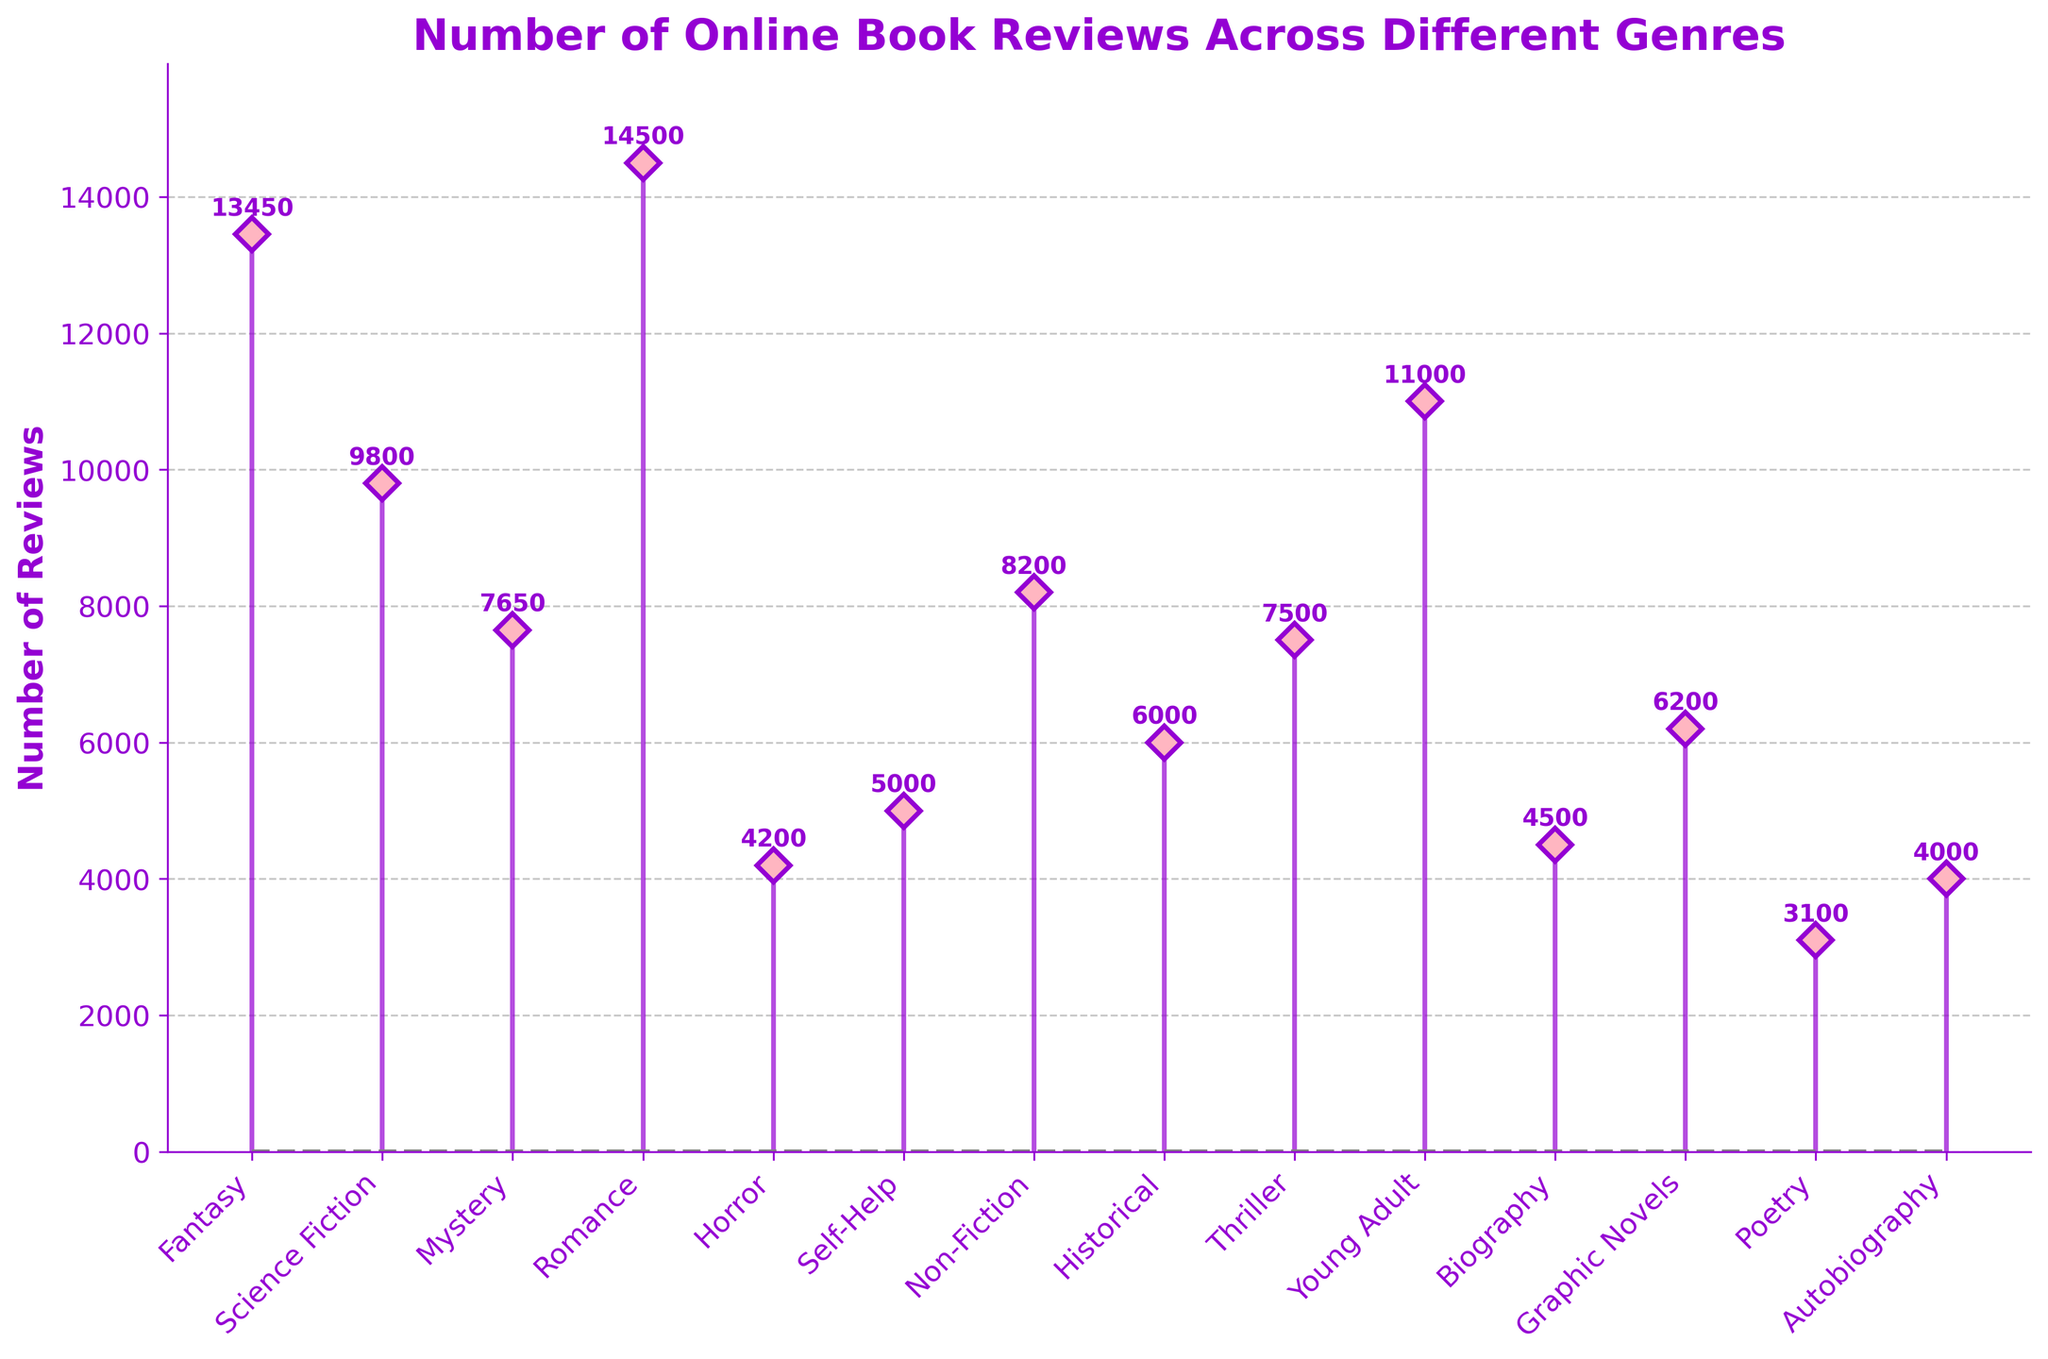What is the title of the plot? The title is usually displayed at the top of the plot, providing a summary of what the figure is about. Here, it states "Number of Online Book Reviews Across Different Genres".
Answer: Number of Online Book Reviews Across Different Genres Which genre has the most number of reviews? By looking at the highest vertical stem in the plot, we can easily identify the genre with the most reviews. In this case, "Romance" has the highest number of reviews.
Answer: Romance How many reviews does the "Science Fiction" genre have? Locate the "Science Fiction" genre along the x-axis and follow the stem line to the point where it intersects the y-axis to see the number of reviews. Here, "Science Fiction" has 9800 reviews.
Answer: 9800 What are the bottom and top values of the y-axis? Check the y-axis to find the lowest and highest values indicated. The bottom value is 0, and the top value is slightly higher than the most reviewed genre, around 16000.
Answer: 0 and 16000 Which genre has fewer reviews, "Thriller" or "Non-Fiction"? Compare the heights of the stems corresponding to "Thriller" and "Non-Fiction". The "Thriller" genre has 7500 reviews, while "Non-Fiction" has 8200 reviews. Therefore, "Thriller" has fewer reviews.
Answer: Thriller How many genres have more than 10,000 reviews? Count the number of stems that exceed the 10,000 mark on the y-axis. The genres "Fantasy" (13450), "Romance" (14500), and "Young Adult" (11000) each have more than 10,000 reviews. Thus, three genres have more than 10,000 reviews.
Answer: 3 What's the difference in the number of reviews between "Fantasy" and "Poetry"? Subtract the number of reviews of "Poetry" from that of "Fantasy". "Fantasy" has 13450 reviews and "Poetry" has 3100 reviews. The difference is 13450 - 3100 = 10350.
Answer: 10350 I'm interested in genres with around 6000 reviews. Which genres fit this profile? Look at the stems closest to the 6000 mark on the y-axis. In this plot, both "Historical" and "Graphic Novels" have close reviews, with 6000 and 6200 reviews respectively.
Answer: Historical, Graphic Novels Is the number of reviews for "Biography" higher than for "Horror"? Compare the stems for "Biography" and "Horror". "Biography" has 4500 reviews while "Horror" has 4200 reviews. Therefore, "Biography" has more reviews than "Horror".
Answer: Yes What is the average number of reviews for "Mystery", "Thriller", and "Horror"? Add the number of reviews for the three genres and divide by 3. "Mystery" has 7650, "Thriller" has 7500, and "Horror" has 4200. The sum is 19350, and the average is 19350 / 3 = 6450.
Answer: 6450 